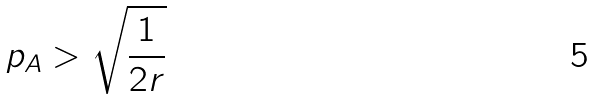Convert formula to latex. <formula><loc_0><loc_0><loc_500><loc_500>p _ { A } > \sqrt { \frac { 1 } { 2 r } }</formula> 